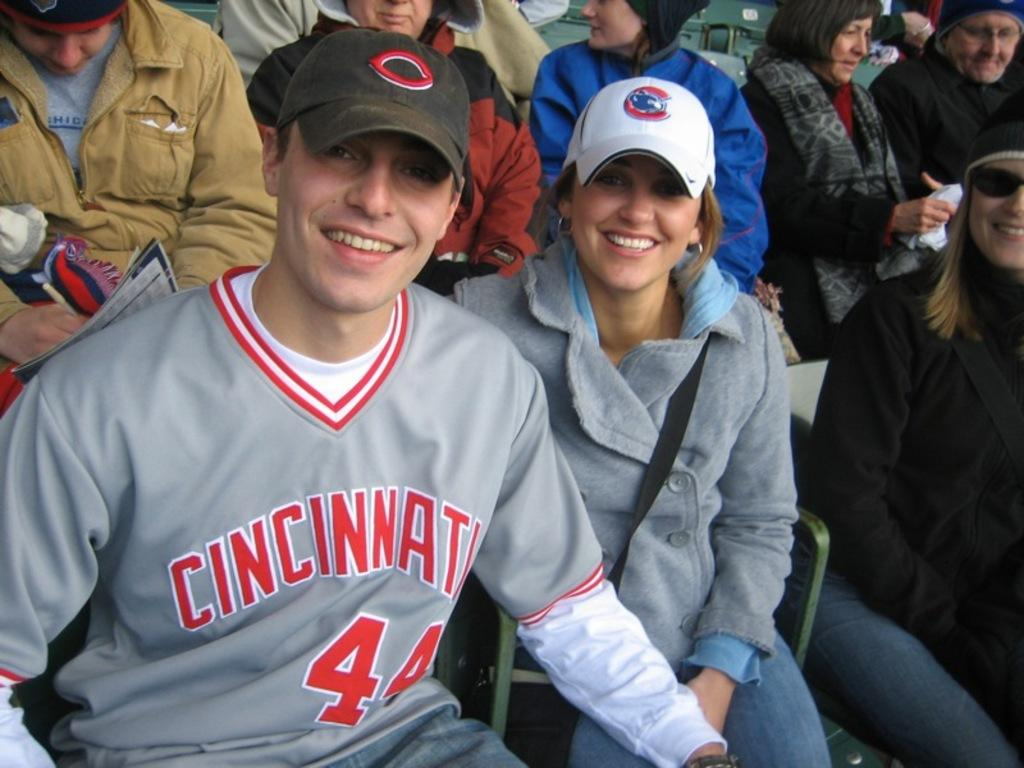<image>
Present a compact description of the photo's key features. Two sports fans, a man and his significant other attending a Cincinnati game. 